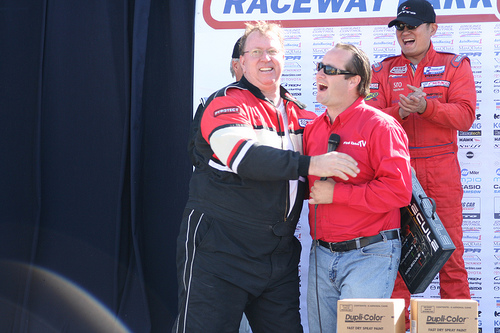<image>
Is there a man one behind the man two? No. The man one is not behind the man two. From this viewpoint, the man one appears to be positioned elsewhere in the scene. 